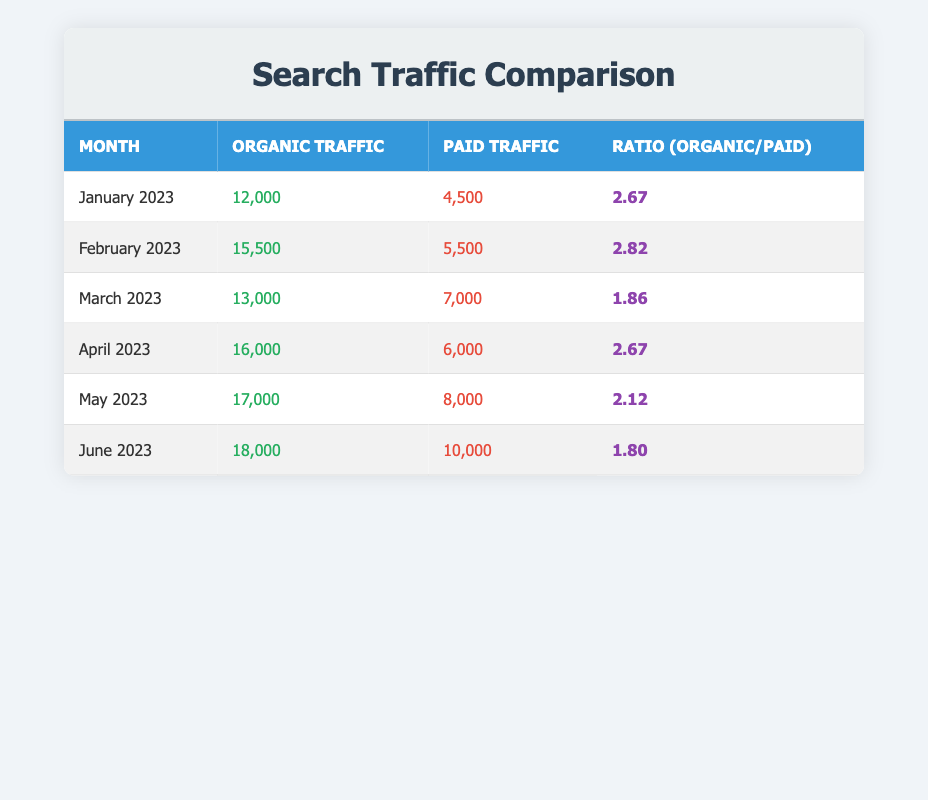What was the organic traffic for April 2023? The table shows that for April 2023, the organic traffic is listed as 16,000.
Answer: 16,000 What is the paid traffic in February 2023? According to the table, the paid traffic for February 2023 is 5,500.
Answer: 5,500 Was the organic traffic higher in March than in January? In March 2023, the organic traffic was 13,000, while in January 2023, it was 12,000. Since 13,000 is greater than 12,000, the statement is true.
Answer: Yes What is the average organic traffic over these six months? The organic traffic values are 12,000, 15,500, 13,000, 16,000, 17,000, and 18,000. To find the average, first add these values: 12,000 + 15,500 + 13,000 + 16,000 + 17,000 + 18,000 = 91,500. Then divide by the number of months, which is 6: 91,500 / 6 = 15,250.
Answer: 15,250 Did the ratio of organic to paid traffic decrease from January to June? The ratio in January 2023 is 2.67, while in June 2023 it is 1.80. By comparing these values, we see that 2.67 is greater than 1.80, indicating a decrease in the ratio over this time period.
Answer: Yes 